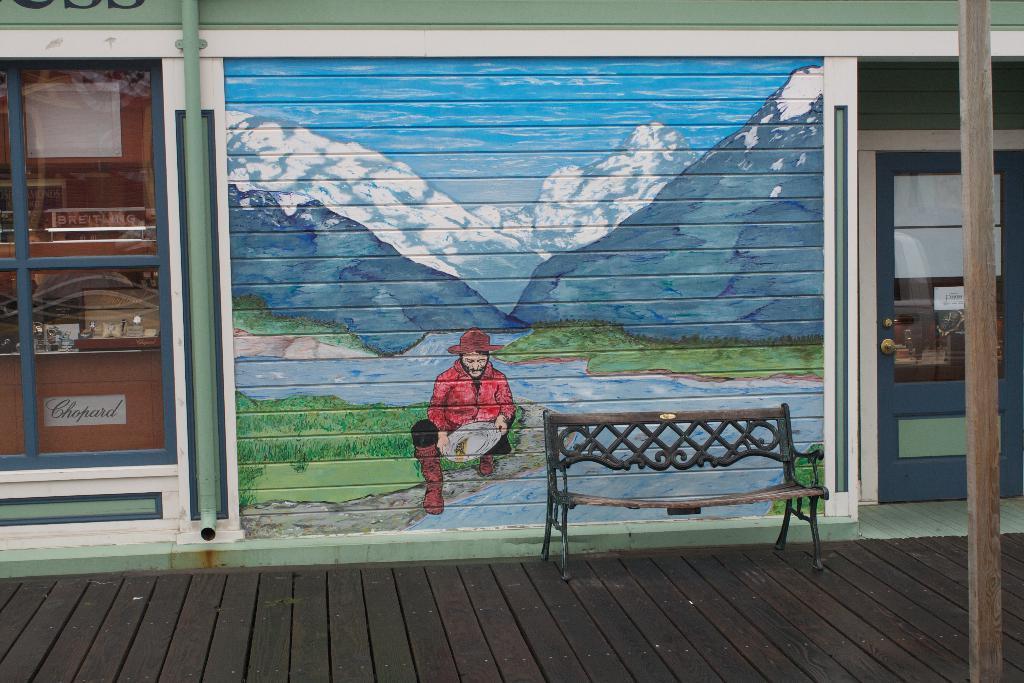In one or two sentences, can you explain what this image depicts? In the foreground I can see a bench on the floor. In the background I can see a shop, wall and a wall painting. This image is taken may be during a day. 